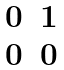Convert formula to latex. <formula><loc_0><loc_0><loc_500><loc_500>\begin{matrix} 0 & 1 \\ 0 & 0 \end{matrix}</formula> 